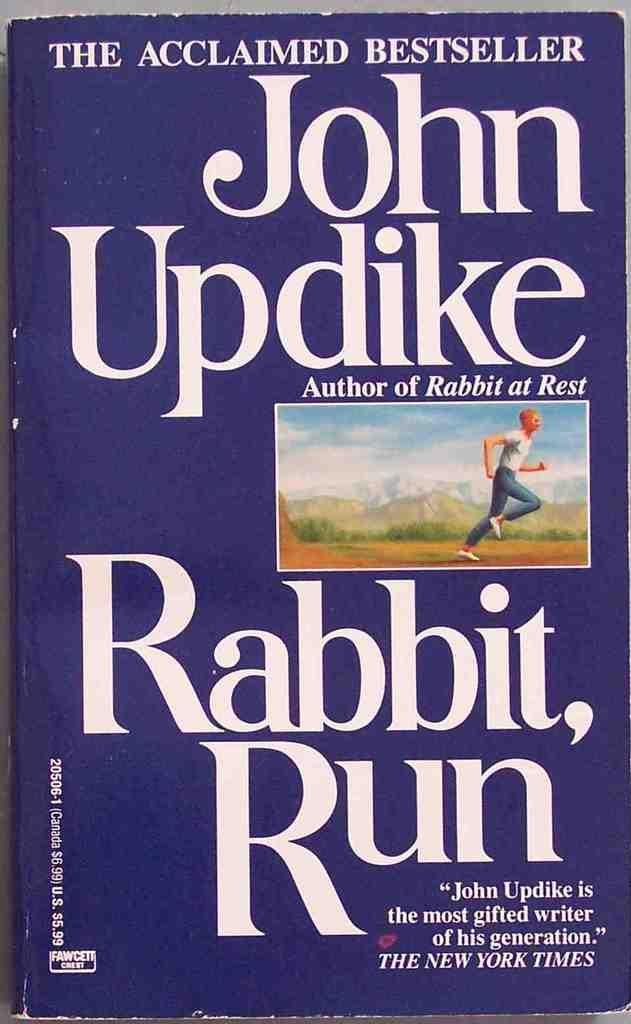<image>
Present a compact description of the photo's key features. The book Run Rabbit, written by John Updike. 